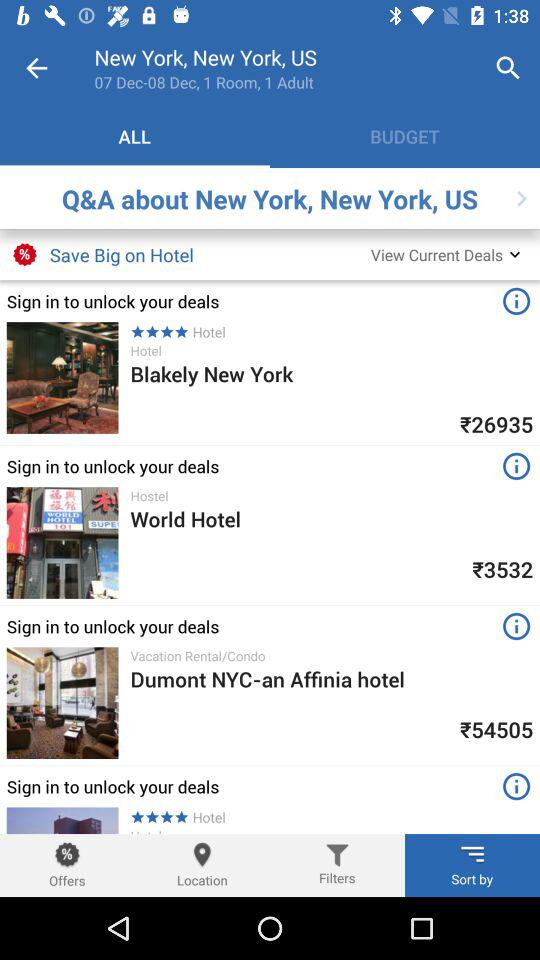What is the location? The location is New York, US. 